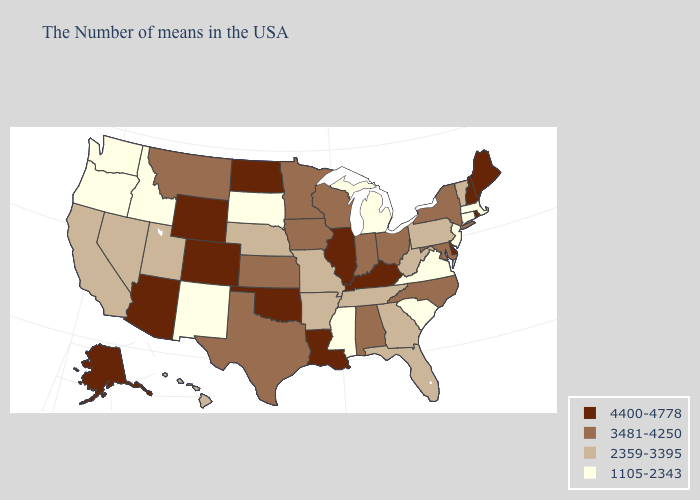Name the states that have a value in the range 4400-4778?
Give a very brief answer. Maine, Rhode Island, New Hampshire, Delaware, Kentucky, Illinois, Louisiana, Oklahoma, North Dakota, Wyoming, Colorado, Arizona, Alaska. Does Michigan have the same value as Virginia?
Concise answer only. Yes. Name the states that have a value in the range 4400-4778?
Quick response, please. Maine, Rhode Island, New Hampshire, Delaware, Kentucky, Illinois, Louisiana, Oklahoma, North Dakota, Wyoming, Colorado, Arizona, Alaska. What is the lowest value in the West?
Keep it brief. 1105-2343. What is the highest value in states that border South Dakota?
Concise answer only. 4400-4778. Does Washington have the highest value in the West?
Quick response, please. No. Which states have the lowest value in the Northeast?
Quick response, please. Massachusetts, Connecticut, New Jersey. What is the value of Missouri?
Write a very short answer. 2359-3395. Which states have the lowest value in the West?
Be succinct. New Mexico, Idaho, Washington, Oregon. What is the lowest value in the USA?
Answer briefly. 1105-2343. What is the value of Louisiana?
Answer briefly. 4400-4778. What is the value of North Dakota?
Write a very short answer. 4400-4778. What is the lowest value in the Northeast?
Write a very short answer. 1105-2343. How many symbols are there in the legend?
Keep it brief. 4. Does Delaware have the highest value in the South?
Short answer required. Yes. 